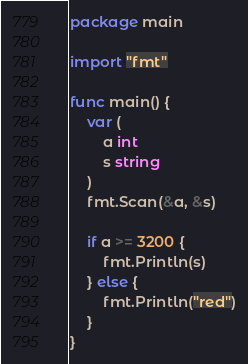Convert code to text. <code><loc_0><loc_0><loc_500><loc_500><_Go_>package main

import "fmt"

func main() {
	var (
		a int
		s string
	)
	fmt.Scan(&a, &s)

	if a >= 3200 {
		fmt.Println(s)
	} else {
		fmt.Println("red")
	}
}
</code> 